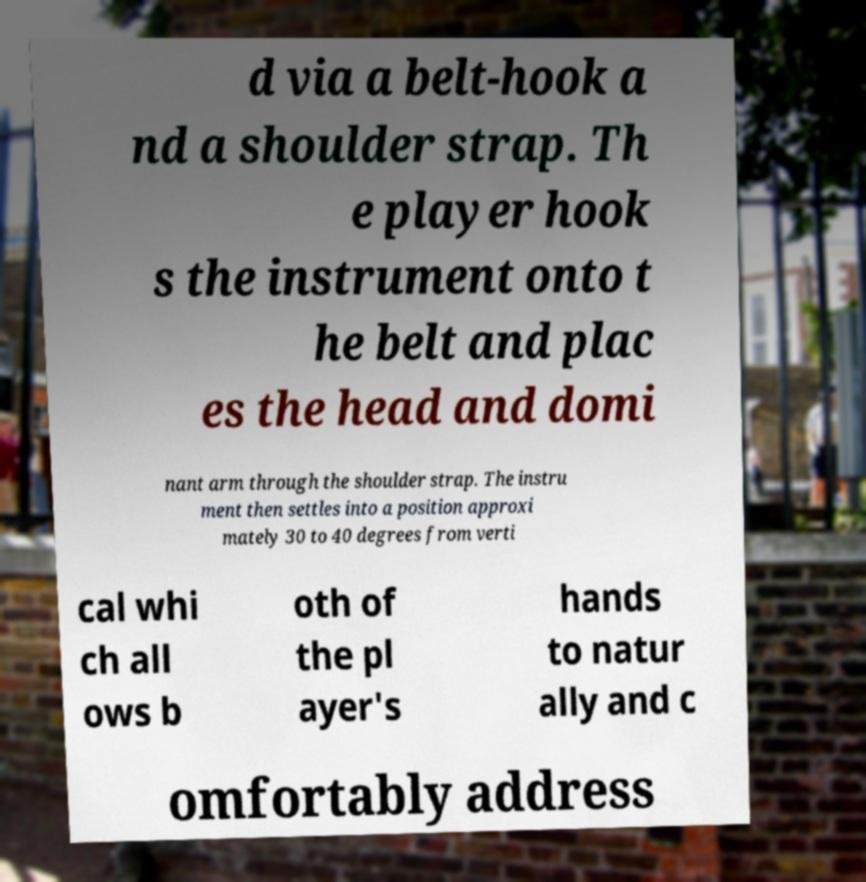Can you read and provide the text displayed in the image?This photo seems to have some interesting text. Can you extract and type it out for me? d via a belt-hook a nd a shoulder strap. Th e player hook s the instrument onto t he belt and plac es the head and domi nant arm through the shoulder strap. The instru ment then settles into a position approxi mately 30 to 40 degrees from verti cal whi ch all ows b oth of the pl ayer's hands to natur ally and c omfortably address 